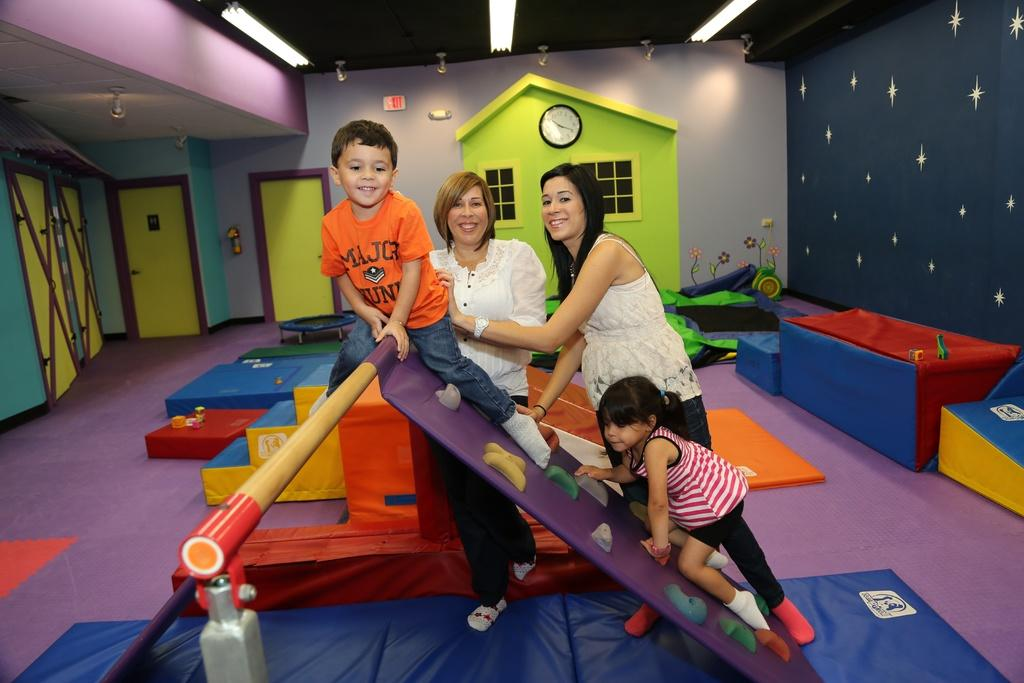How many kids are in the image? There are two kids in the image. How many women are in the image? There are two women in the image. What is the setting of the image? The setting is a kids play room. What is the color of the walls in the room? The walls in the room are colorful. What is visible at the back of the room? There is a door visible in the back of the room. What is installed feature can be seen over the ceiling in the room? There are lights over the ceiling in the room. What type of substance is the achiever using to paint their toe in the image? There is no achiever, substance, or toe painting activity present in the image. 